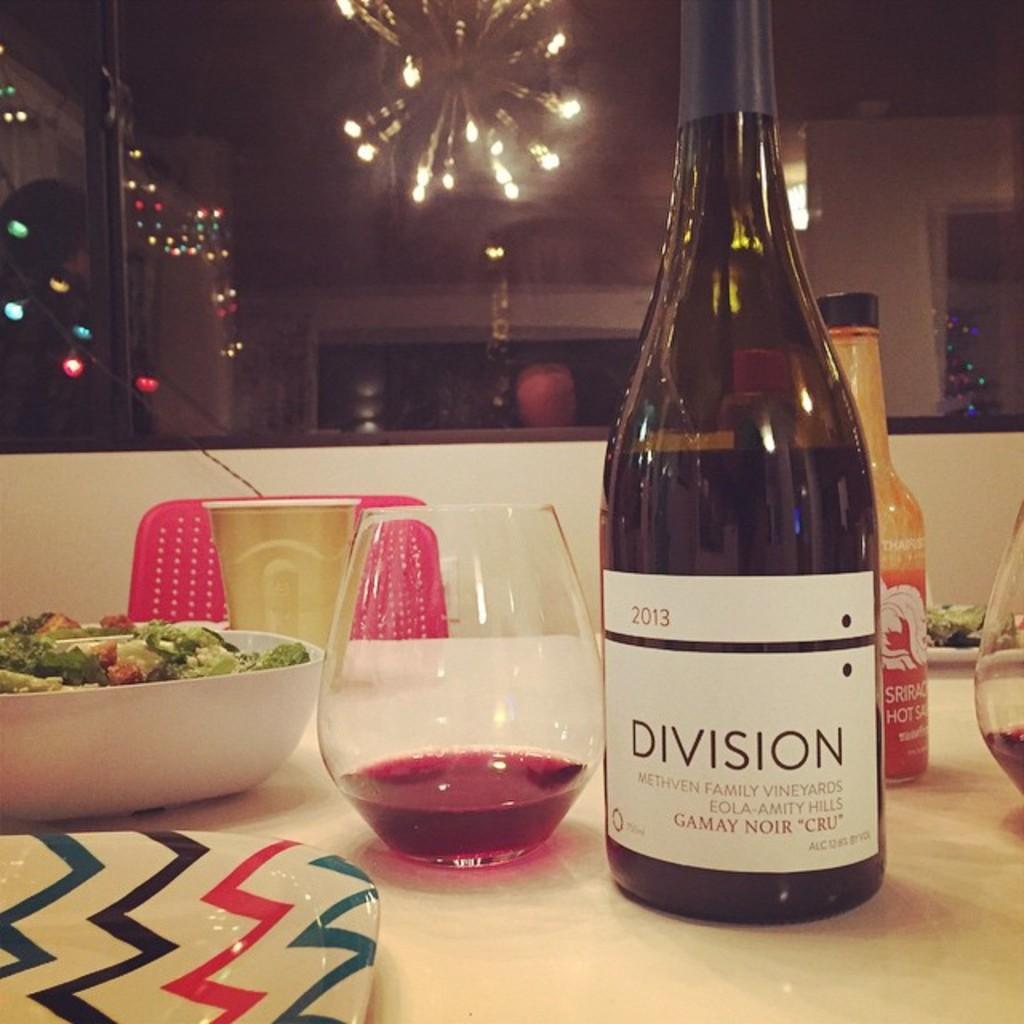In one or two sentences, can you explain what this image depicts? This picture shows a wine bottle and a glass and a bowl and a plate on the table. 